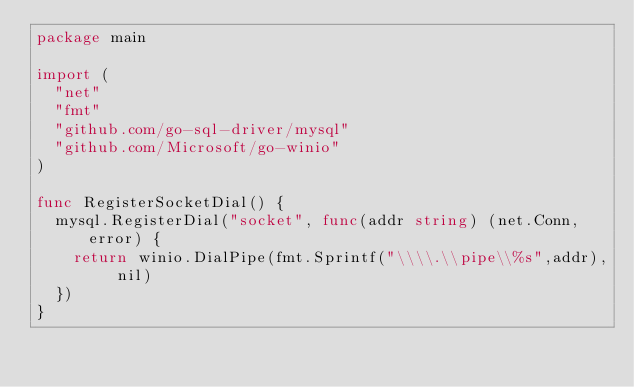Convert code to text. <code><loc_0><loc_0><loc_500><loc_500><_Go_>package main

import (
	"net"
	"fmt"
	"github.com/go-sql-driver/mysql"
	"github.com/Microsoft/go-winio"
)

func RegisterSocketDial() {
	mysql.RegisterDial("socket", func(addr string) (net.Conn, error) {
		return winio.DialPipe(fmt.Sprintf("\\\\.\\pipe\\%s",addr), nil)
	})
}
</code> 